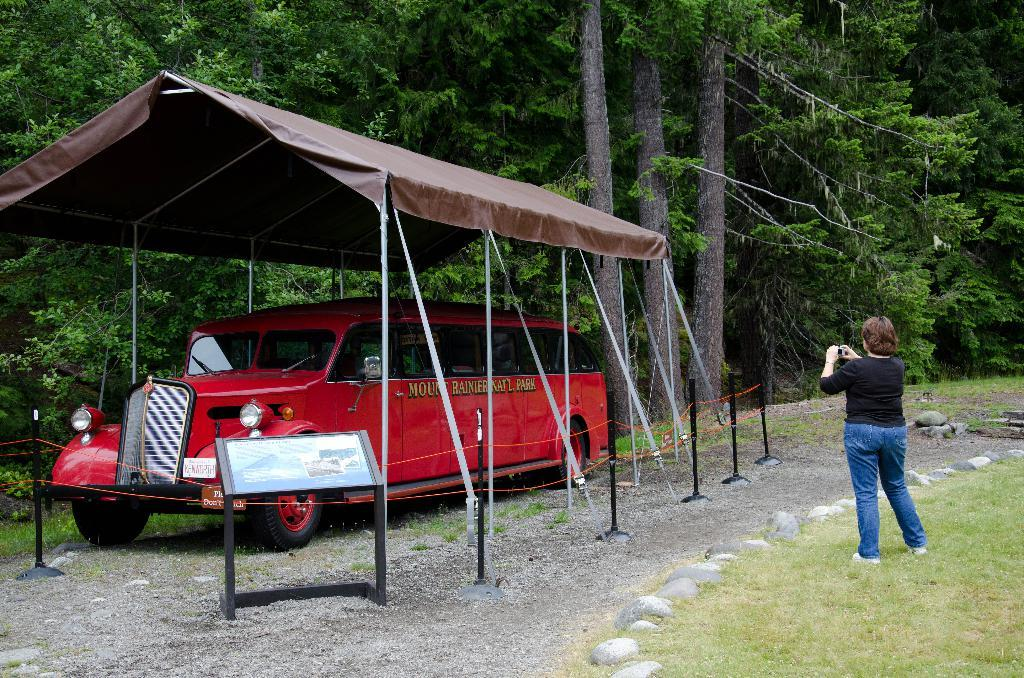What is located under the tent in the image? There is a car under a tent in the image. Who is present in the image besides the car? There is a woman standing on the land in the image. What can be seen in the background of the image? There are trees in the background of the image. What type of drink is the woman holding in the image? There is no drink visible in the image; the woman is not holding anything. What historical event is taking place in the image? There is no indication of a historical event in the image. 